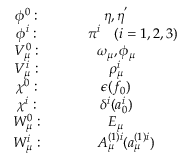<formula> <loc_0><loc_0><loc_500><loc_500>\begin{array} { c c } { { \phi ^ { 0 } \colon } } & { { \eta , \eta ^ { ^ { \prime } } } } \\ { { \phi ^ { i } \colon } } & { { \pi ^ { i } ( i = 1 , 2 , 3 ) } } \\ { { V _ { \mu } ^ { 0 } \colon } } & { { \omega _ { \mu } , \phi _ { \mu } } } \\ { { V _ { \mu } ^ { i } \colon } } & { { \rho _ { \mu } ^ { i } } } \\ { { \chi ^ { 0 } \colon } } & { { \epsilon ( f _ { 0 } ) } } \\ { { \chi ^ { i } \colon } } & { { \delta ^ { i } ( a _ { 0 } ^ { i } ) } } \\ { { W _ { \mu } ^ { 0 } \colon } } & { { E _ { \mu } } } \\ { { W _ { \mu } ^ { i } \colon } } & { { A _ { \mu } ^ { ( 1 ) i } ( a _ { \mu } ^ { ( 1 ) i } ) } } \end{array}</formula> 